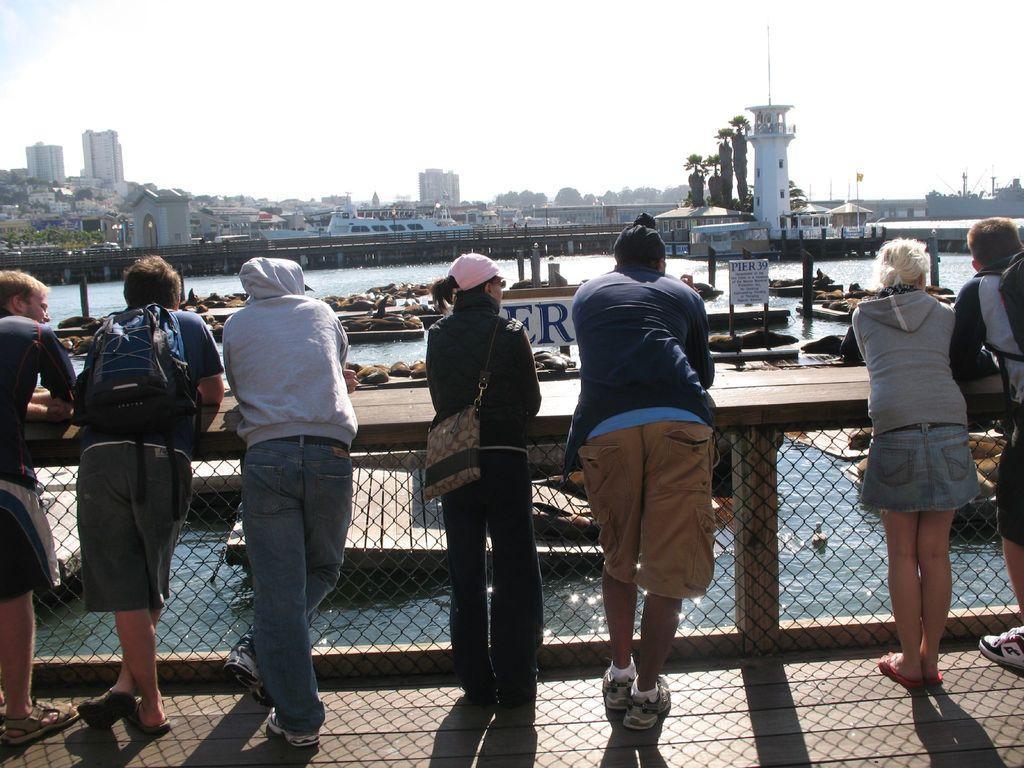Describe this image in one or two sentences. In the foreground of the picture I can see a few persons standing on the wooden floor and they are carrying a bag. In the background, I can see the water, ships, buildings and trees. There are clouds in the sky. 